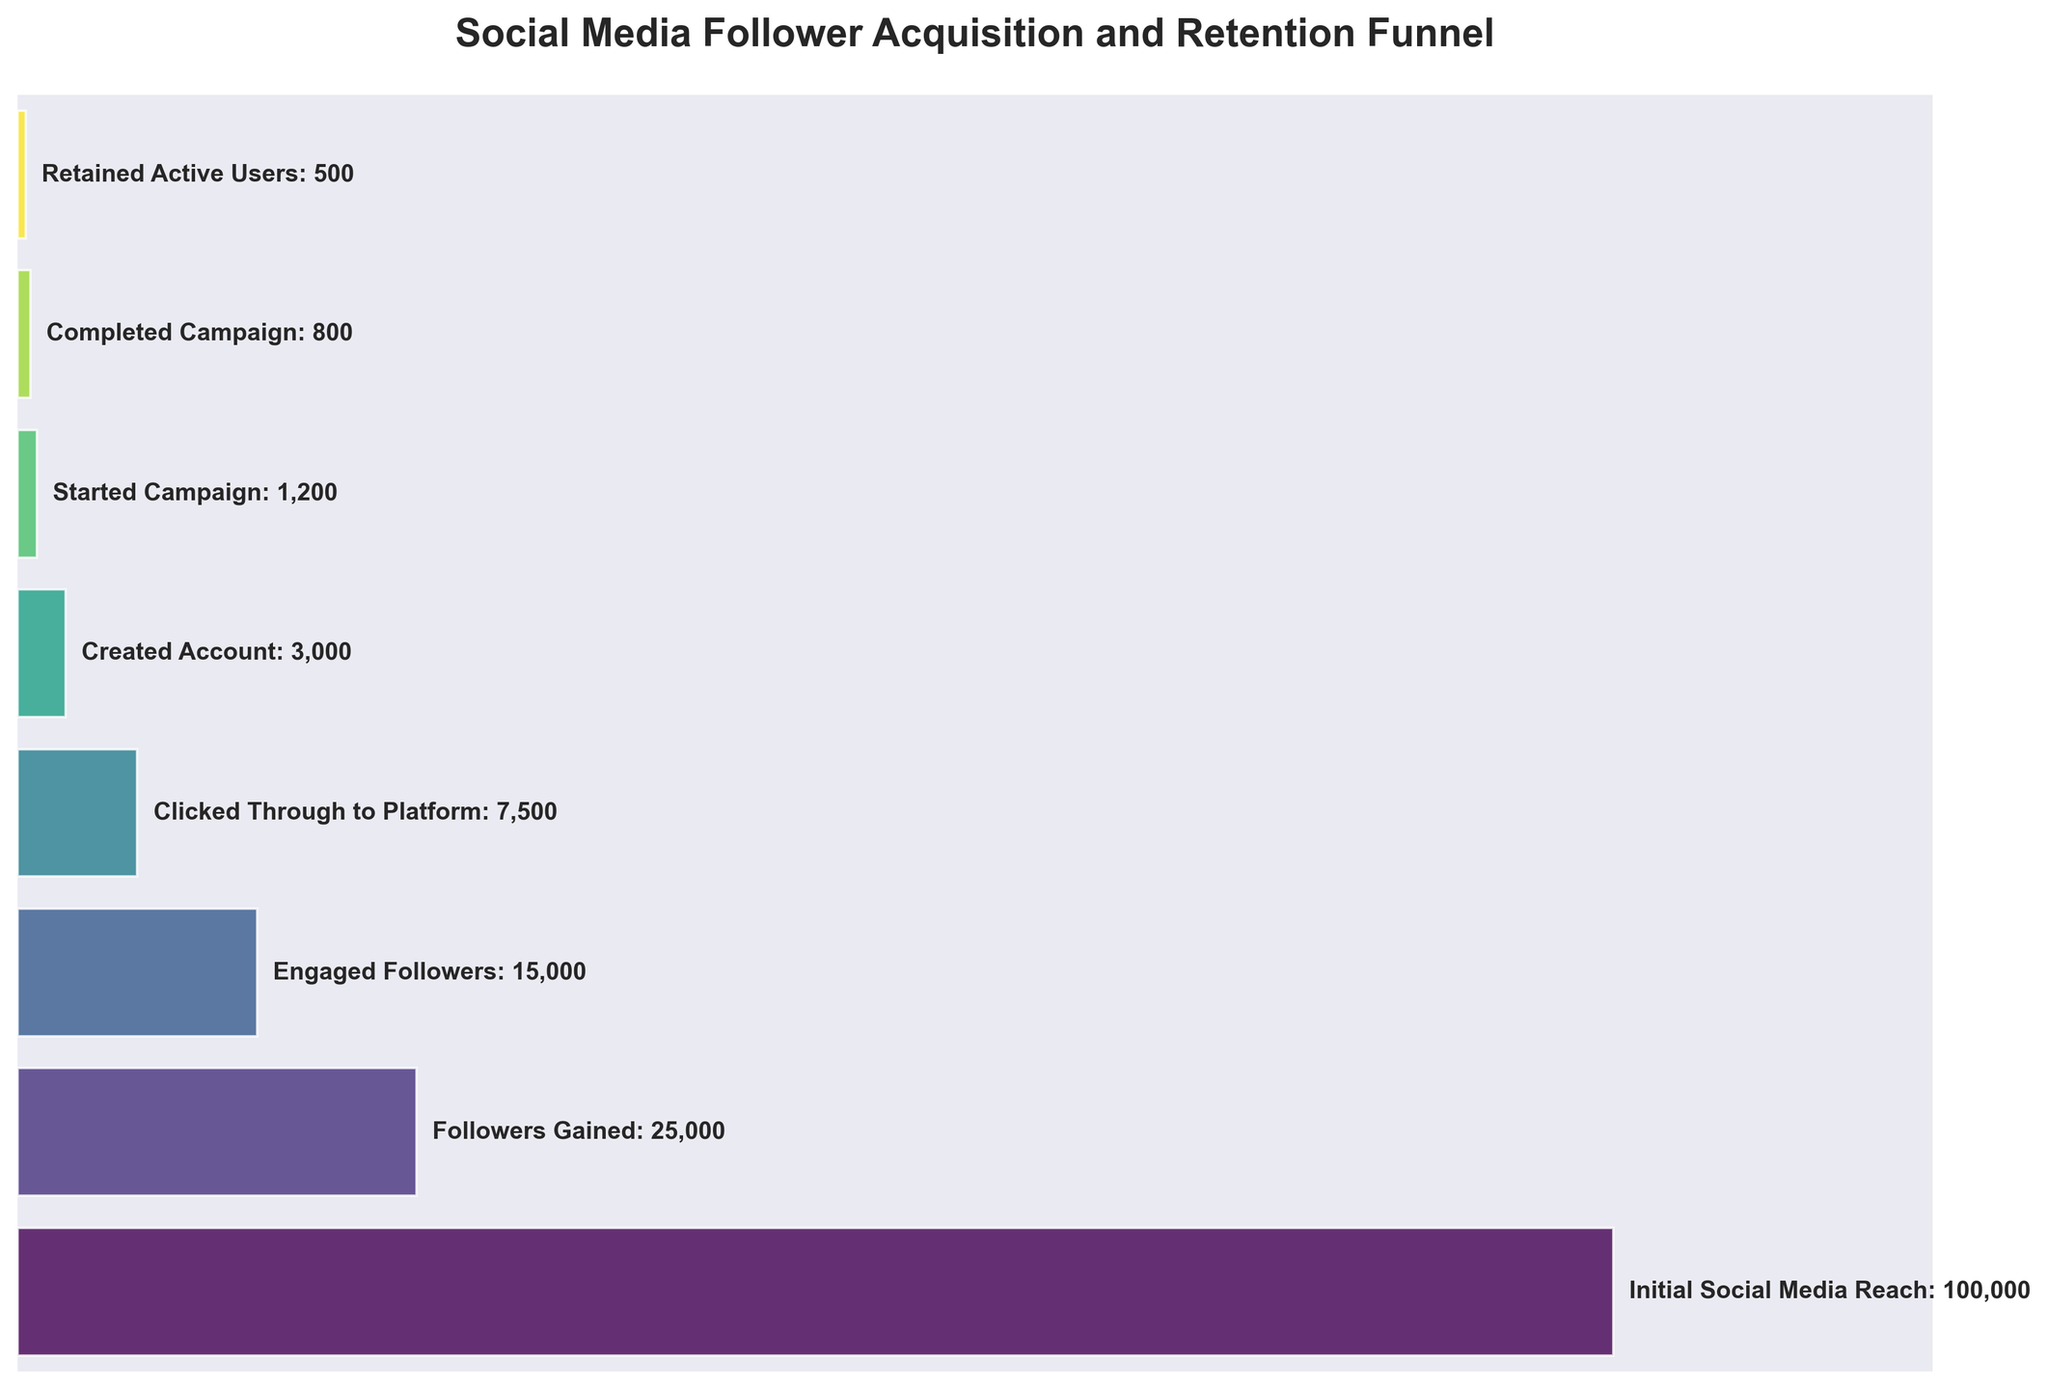What's the title of the chart? The title is usually displayed prominently at the top of the figure. In this case, it is "Social Media Follower Acquisition and Retention Funnel". This title reflects the main focus of the data shown in the figure.
Answer: Social Media Follower Acquisition and Retention Funnel How many stages are represented in the Funnel Chart? The stages are listed vertically within the figure. By counting these stages, we see that there are eight stages.
Answer: 8 Which stage has the highest number of users? The number of users in each stage is indicated next to the stage names. The stage with the highest number of users is "Initial Social Media Reach" with 100,000 users.
Answer: Initial Social Media Reach How many users clicked through to the platform? The figure shows that the "Clicked Through to Platform" stage has 7,500 users. This information is next to the corresponding stage name.
Answer: 7,500 What's the difference in user numbers between the "Followers Gained" and "Created Account" stages? To find the difference, subtract the number of users in the "Created Account" stage from the "Followers Gained" stage: 25,000 - 3,000 = 22,000.
Answer: 22,000 Which stage has the smallest number of users? Comparing the user numbers across all stages, we see that "Retained Active Users" has the smallest number with 500 users.
Answer: Retained Active Users What's the sum of users in the "Started Campaign" and "Completed Campaign" stages? To find the sum, add the number of users in the "Started Campaign" stage (1,200) to the "Completed Campaign" stage (800): 1,200 + 800 = 2,000.
Answer: 2,000 How many users transitioned from "Created Account" to "Started Campaign"? Subtract the number of users in the "Started Campaign" stage from the "Created Account" stage: 3,000 - 1,200 = 1,800.
Answer: 1,800 Is the number of "Engaged Followers" greater than the number of users who "Created Account"? The "Engaged Followers" stage has 15,000 users, and the "Created Account" stage has 3,000 users. 15,000 is greater than 3,000.
Answer: Yes By what percentage did users decrease from "Initial Social Media Reach" to "Followers Gained"? To find the percentage decrease, subtract the number of "Followers Gained" from "Initial Social Media Reach", divide by "Initial Social Media Reach", and multiply by 100. (100,000 - 25,000) / 100,000 * 100 = 75%.
Answer: 75% 